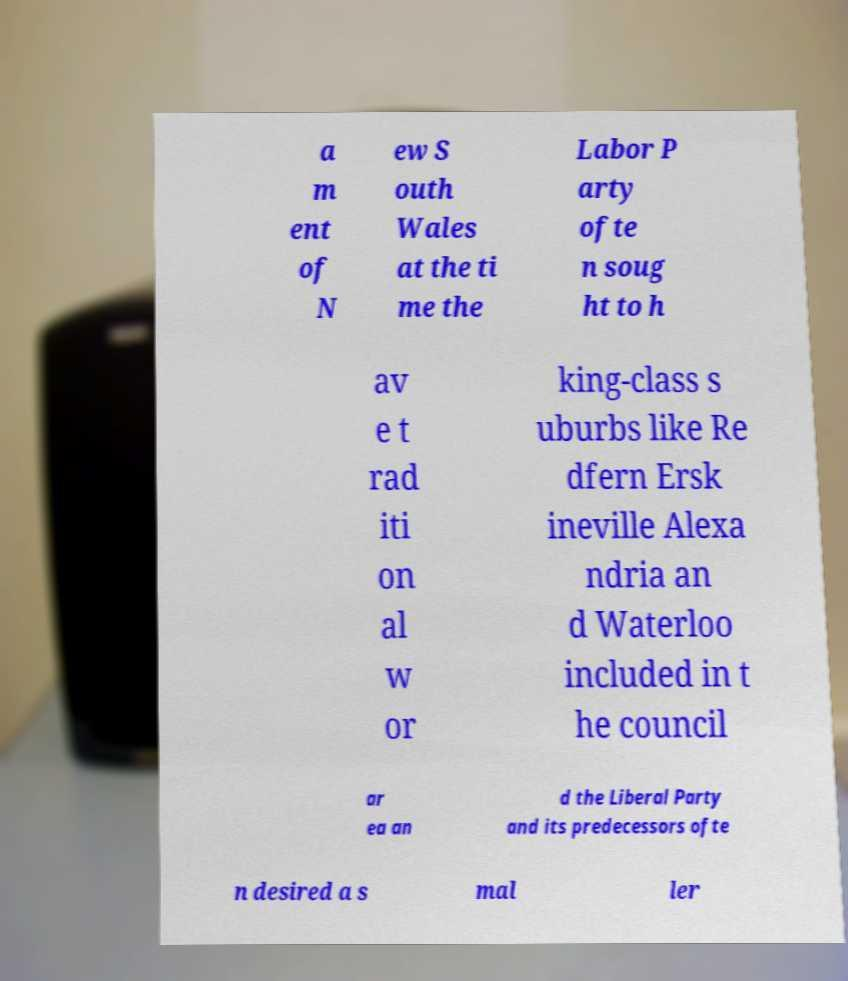There's text embedded in this image that I need extracted. Can you transcribe it verbatim? a m ent of N ew S outh Wales at the ti me the Labor P arty ofte n soug ht to h av e t rad iti on al w or king-class s uburbs like Re dfern Ersk ineville Alexa ndria an d Waterloo included in t he council ar ea an d the Liberal Party and its predecessors ofte n desired a s mal ler 